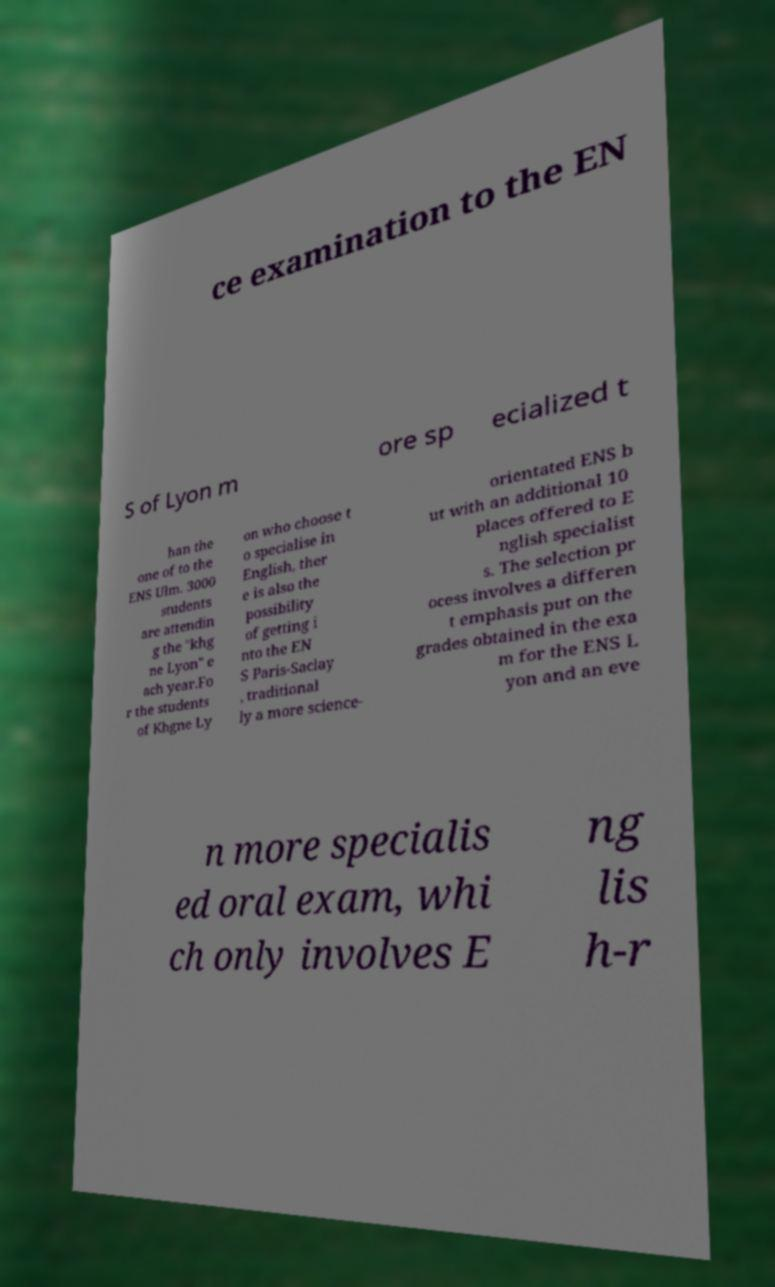For documentation purposes, I need the text within this image transcribed. Could you provide that? ce examination to the EN S of Lyon m ore sp ecialized t han the one of to the ENS Ulm. 3000 students are attendin g the "khg ne Lyon" e ach year.Fo r the students of Khgne Ly on who choose t o specialise in English, ther e is also the possibility of getting i nto the EN S Paris-Saclay , traditional ly a more science- orientated ENS b ut with an additional 10 places offered to E nglish specialist s. The selection pr ocess involves a differen t emphasis put on the grades obtained in the exa m for the ENS L yon and an eve n more specialis ed oral exam, whi ch only involves E ng lis h-r 